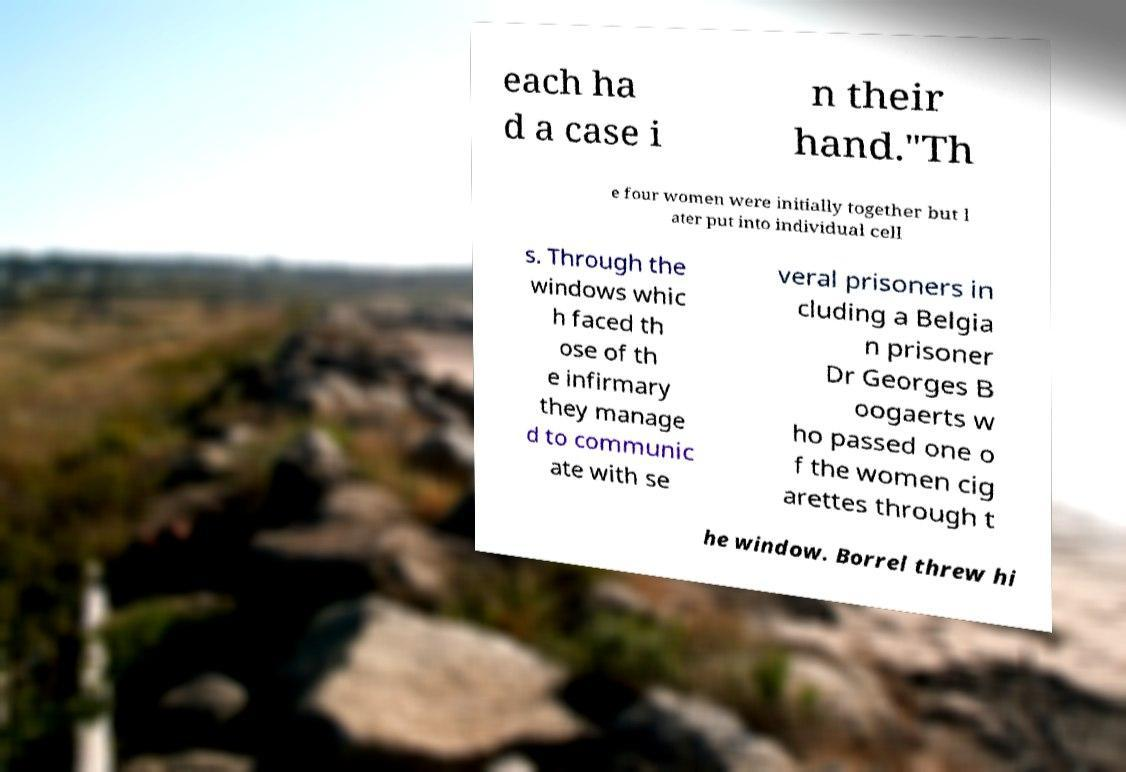Can you read and provide the text displayed in the image?This photo seems to have some interesting text. Can you extract and type it out for me? each ha d a case i n their hand."Th e four women were initially together but l ater put into individual cell s. Through the windows whic h faced th ose of th e infirmary they manage d to communic ate with se veral prisoners in cluding a Belgia n prisoner Dr Georges B oogaerts w ho passed one o f the women cig arettes through t he window. Borrel threw hi 